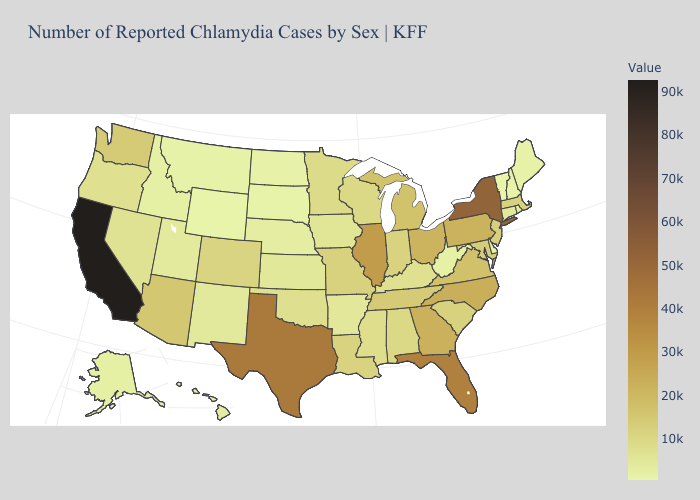Does Vermont have the lowest value in the USA?
Concise answer only. Yes. Among the states that border Wyoming , does Colorado have the highest value?
Concise answer only. Yes. Among the states that border North Dakota , does South Dakota have the lowest value?
Give a very brief answer. Yes. Does Illinois have the highest value in the MidWest?
Concise answer only. Yes. Does Iowa have the lowest value in the MidWest?
Be succinct. No. Among the states that border Ohio , which have the highest value?
Quick response, please. Pennsylvania. Does Rhode Island have a higher value than Massachusetts?
Be succinct. No. Which states hav the highest value in the Northeast?
Short answer required. New York. 